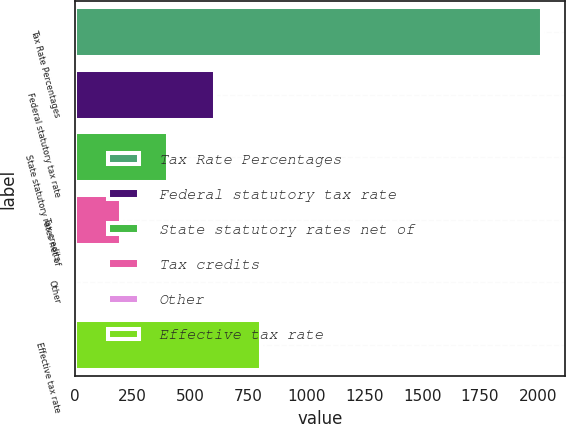Convert chart. <chart><loc_0><loc_0><loc_500><loc_500><bar_chart><fcel>Tax Rate Percentages<fcel>Federal statutory tax rate<fcel>State statutory rates net of<fcel>Tax credits<fcel>Other<fcel>Effective tax rate<nl><fcel>2016<fcel>604.94<fcel>403.36<fcel>201.78<fcel>0.2<fcel>806.52<nl></chart> 